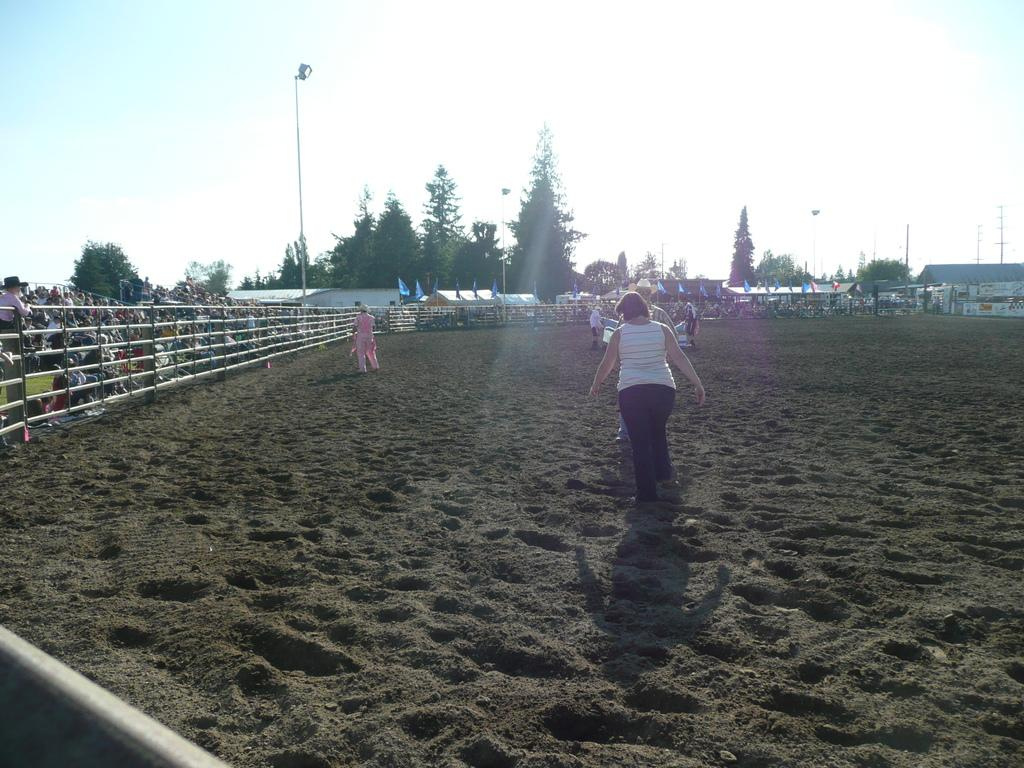Where are the people in the image located? The people in the image are on the sand. What else can be seen in the image besides people? Fencing, poles, trees, and houses are visible in the image. Can you describe the type of fencing in the image? The fencing in the image is made of metal or a similar material. How many houses can be seen in the image? There are at least two houses visible in the image. What type of banana is being used as a prop in the image? There is no banana present in the image. How many vans are visible in the image? There are no vans visible in the image. 